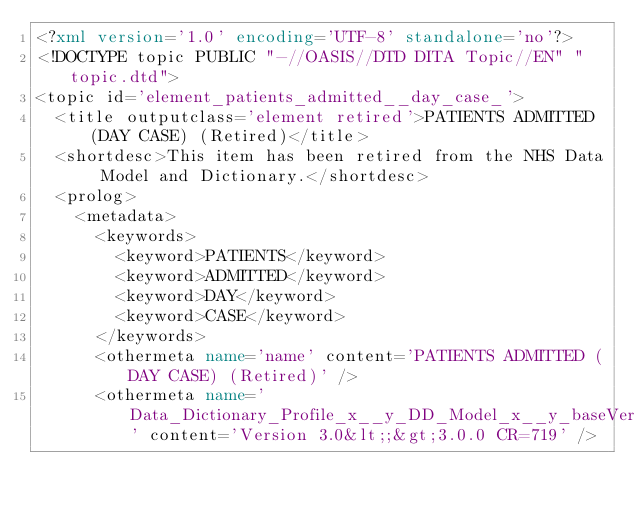<code> <loc_0><loc_0><loc_500><loc_500><_XML_><?xml version='1.0' encoding='UTF-8' standalone='no'?>
<!DOCTYPE topic PUBLIC "-//OASIS//DTD DITA Topic//EN" "topic.dtd">
<topic id='element_patients_admitted__day_case_'>
  <title outputclass='element retired'>PATIENTS ADMITTED (DAY CASE) (Retired)</title>
  <shortdesc>This item has been retired from the NHS Data Model and Dictionary.</shortdesc>
  <prolog>
    <metadata>
      <keywords>
        <keyword>PATIENTS</keyword>
        <keyword>ADMITTED</keyword>
        <keyword>DAY</keyword>
        <keyword>CASE</keyword>
      </keywords>
      <othermeta name='name' content='PATIENTS ADMITTED (DAY CASE) (Retired)' />
      <othermeta name='Data_Dictionary_Profile_x__y_DD_Model_x__y_baseVersion' content='Version 3.0&lt;;&gt;3.0.0 CR=719' /></code> 